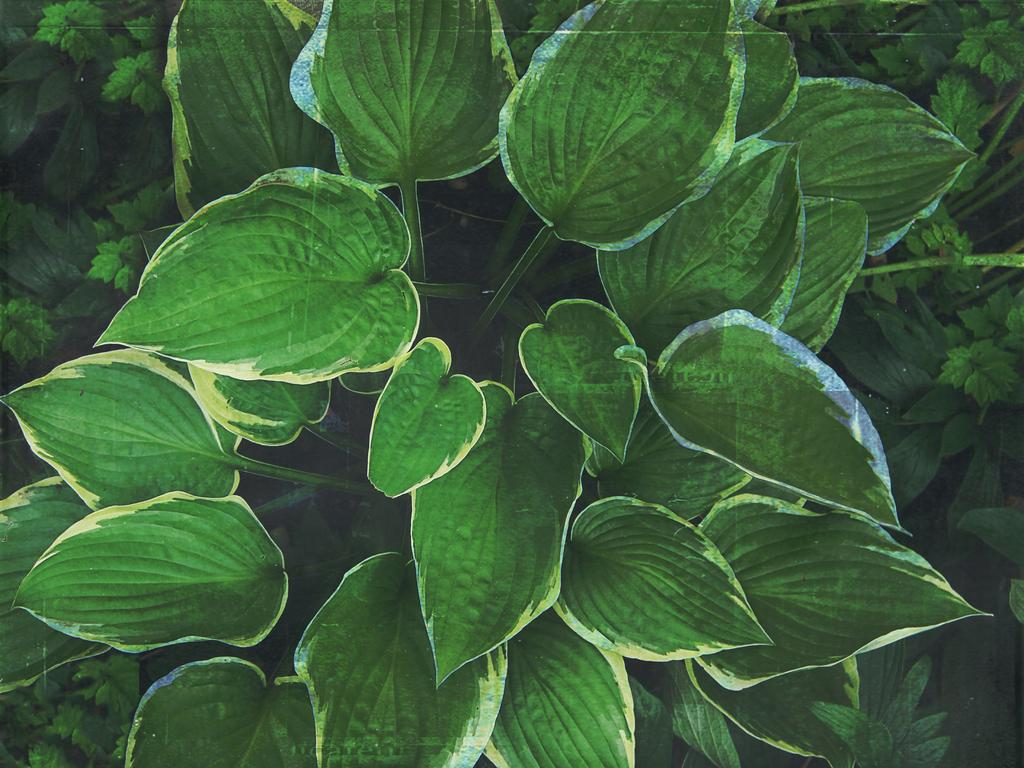What type of vegetation is present in the image? There are green leaves in the image. Can you see a cobweb in the image? There is no mention of a cobweb in the provided fact, and therefore it cannot be confirmed or denied. 